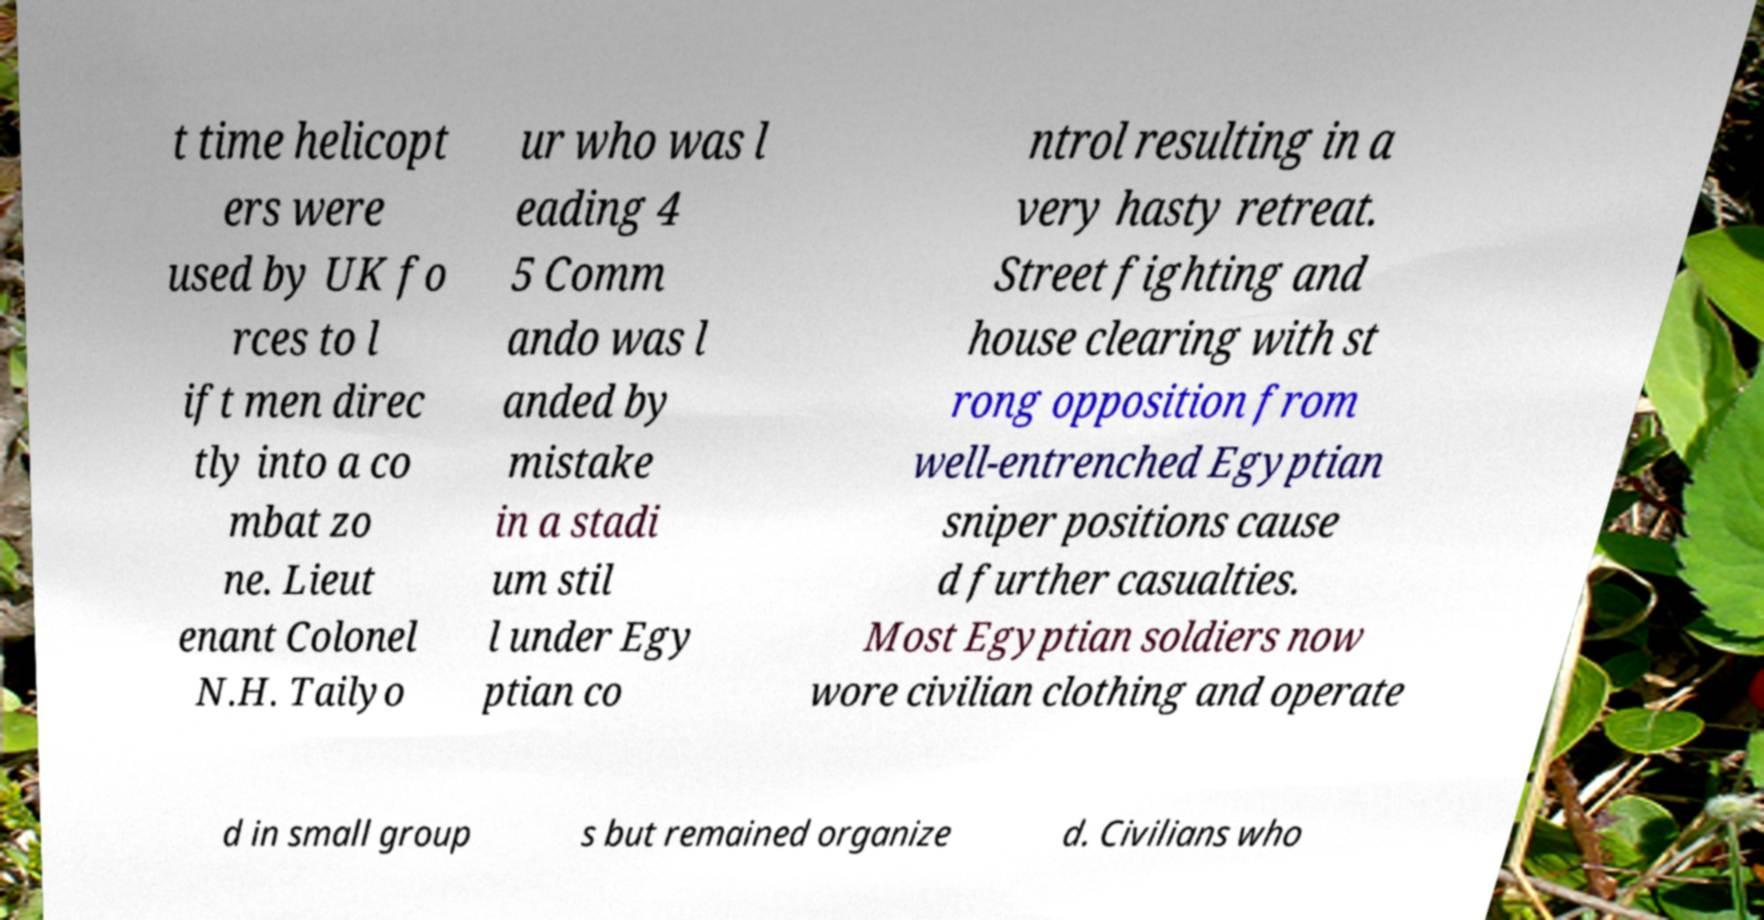Please read and relay the text visible in this image. What does it say? t time helicopt ers were used by UK fo rces to l ift men direc tly into a co mbat zo ne. Lieut enant Colonel N.H. Tailyo ur who was l eading 4 5 Comm ando was l anded by mistake in a stadi um stil l under Egy ptian co ntrol resulting in a very hasty retreat. Street fighting and house clearing with st rong opposition from well-entrenched Egyptian sniper positions cause d further casualties. Most Egyptian soldiers now wore civilian clothing and operate d in small group s but remained organize d. Civilians who 